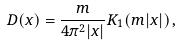<formula> <loc_0><loc_0><loc_500><loc_500>D ( x ) = \frac { m } { 4 \pi ^ { 2 } | x | } K _ { 1 } ( m | x | ) \, ,</formula> 